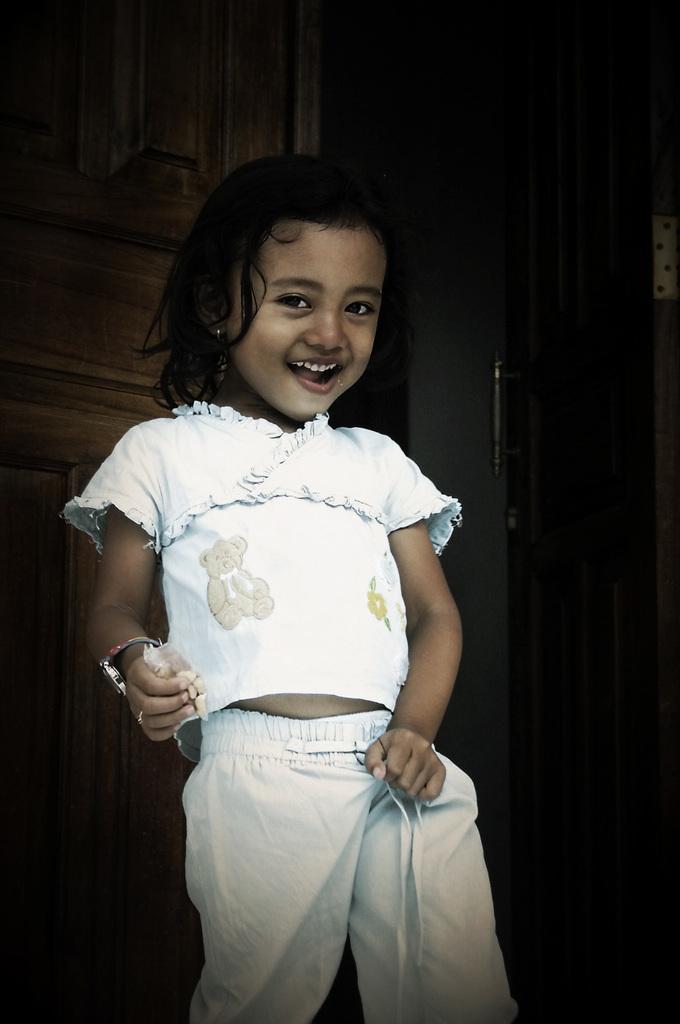Please provide a concise description of this image. In this image we can see a girl holding polythene cover in the hand. 